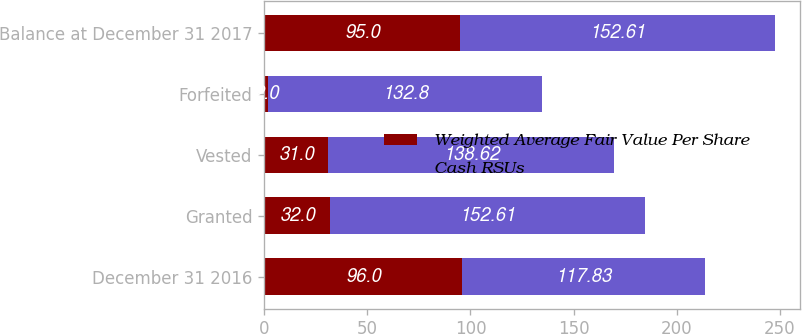Convert chart to OTSL. <chart><loc_0><loc_0><loc_500><loc_500><stacked_bar_chart><ecel><fcel>December 31 2016<fcel>Granted<fcel>Vested<fcel>Forfeited<fcel>Balance at December 31 2017<nl><fcel>Weighted Average Fair Value Per Share<fcel>96<fcel>32<fcel>31<fcel>2<fcel>95<nl><fcel>Cash RSUs<fcel>117.83<fcel>152.61<fcel>138.62<fcel>132.8<fcel>152.61<nl></chart> 